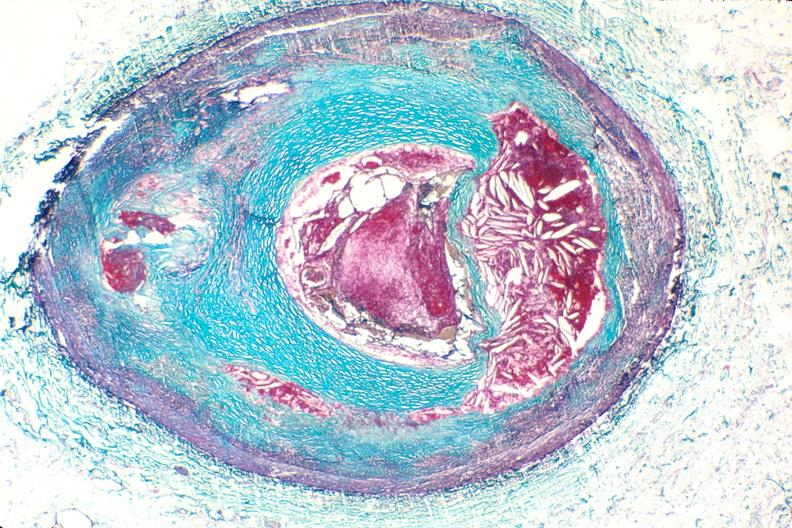does stillborn macerated show right coronary artery, atherosclerosis and acute thrombus?
Answer the question using a single word or phrase. No 